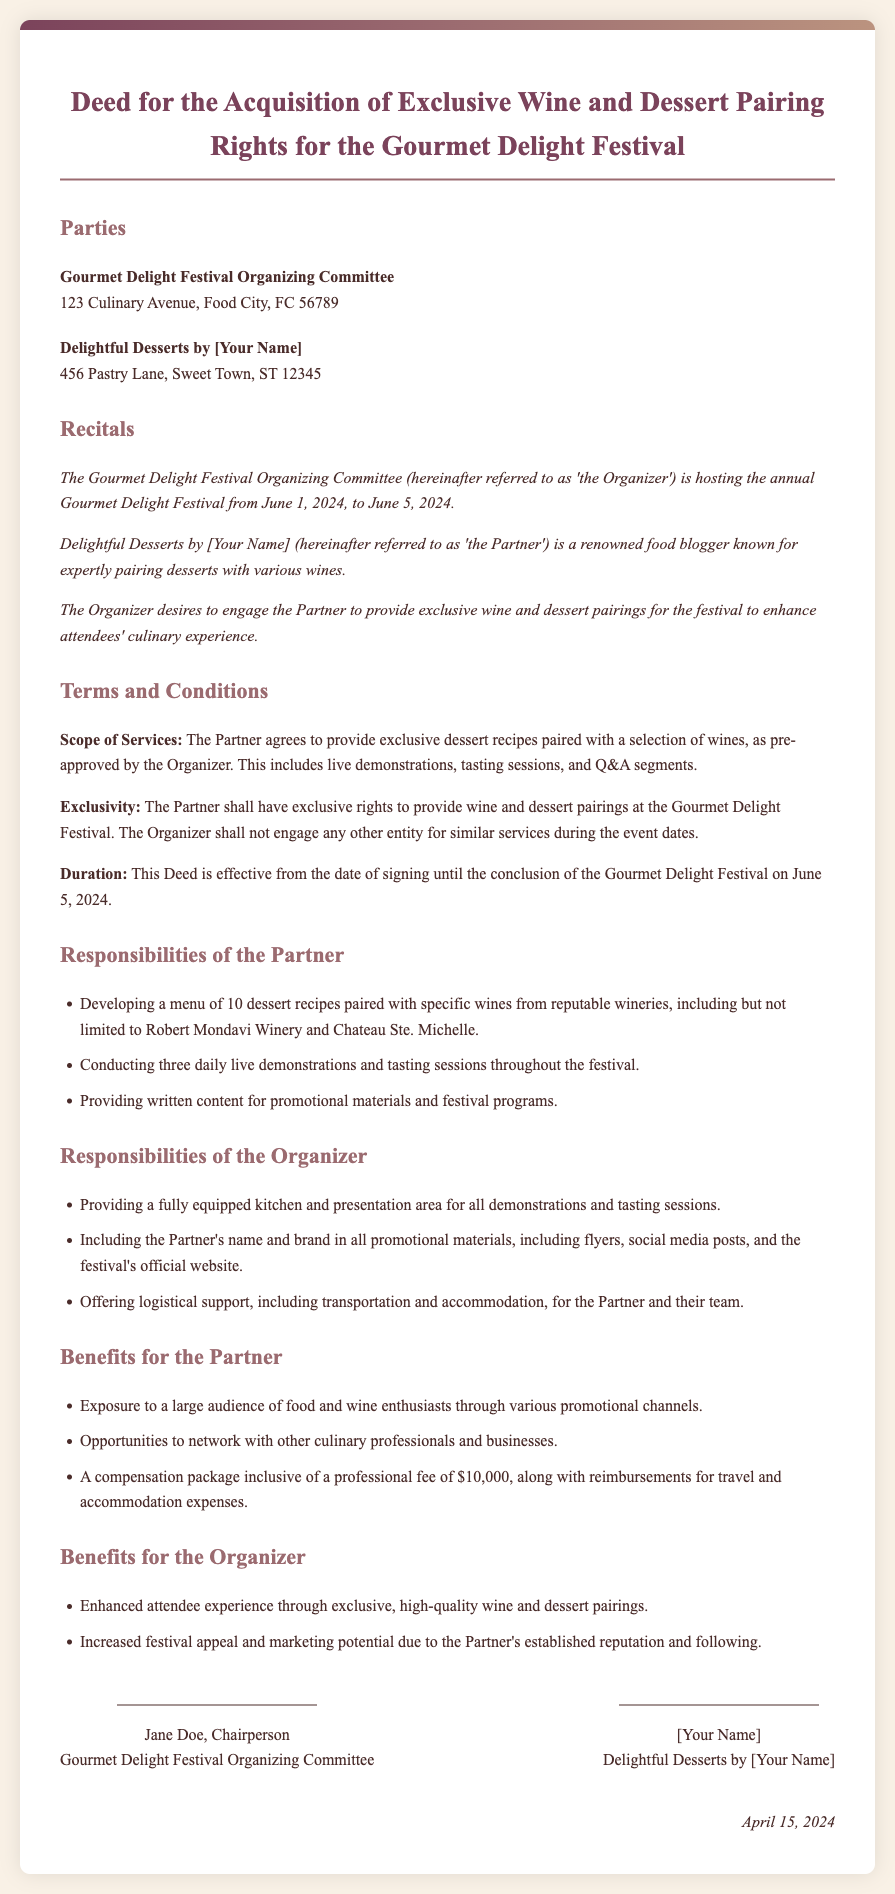What are the event dates? The document specifies that the Gourmet Delight Festival will take place from June 1, 2024, to June 5, 2024.
Answer: June 1, 2024, to June 5, 2024 Who is the Partner? The Partner is identified in the document as "Delightful Desserts by [Your Name]."
Answer: Delightful Desserts by [Your Name] What is the professional fee for the Partner? The compensation package includes a professional fee of $10,000 as stated in the section on benefits for the Partner.
Answer: $10,000 How many dessert recipes must the Partner develop? The Partner is required to develop a menu of 10 dessert recipes as indicated under Responsibilities of the Partner.
Answer: 10 What type of support will the Organizer provide? The Organizer is responsible for offering logistical support, including transportation and accommodation, for the Partner and their team.
Answer: Logistical support What is the total duration of the agreement? The document states that the Deed is effective from the signing date until the conclusion of the festival on June 5, 2024, indicating a total duration of approximately two months.
Answer: Until June 5, 2024 What is one of the responsibilities of the Organizer? The Organizer has the responsibility to provide a fully equipped kitchen and presentation area for all demonstrations and tasting sessions.
Answer: Fully equipped kitchen How many daily live demonstrations must the Partner conduct? The document states that the Partner must conduct three daily live demonstrations and tasting sessions throughout the festival.
Answer: Three 